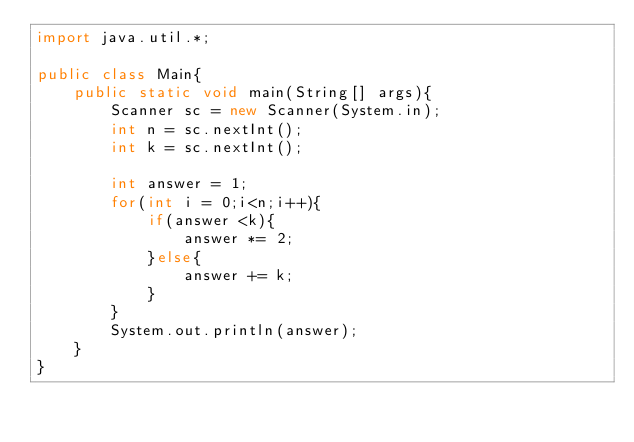<code> <loc_0><loc_0><loc_500><loc_500><_Java_>import java.util.*;

public class Main{
    public static void main(String[] args){
        Scanner sc = new Scanner(System.in);
        int n = sc.nextInt();
        int k = sc.nextInt();

        int answer = 1;
        for(int i = 0;i<n;i++){   
            if(answer <k){
                answer *= 2;
            }else{
                answer += k;
            }
        }
        System.out.println(answer);
    }
}</code> 